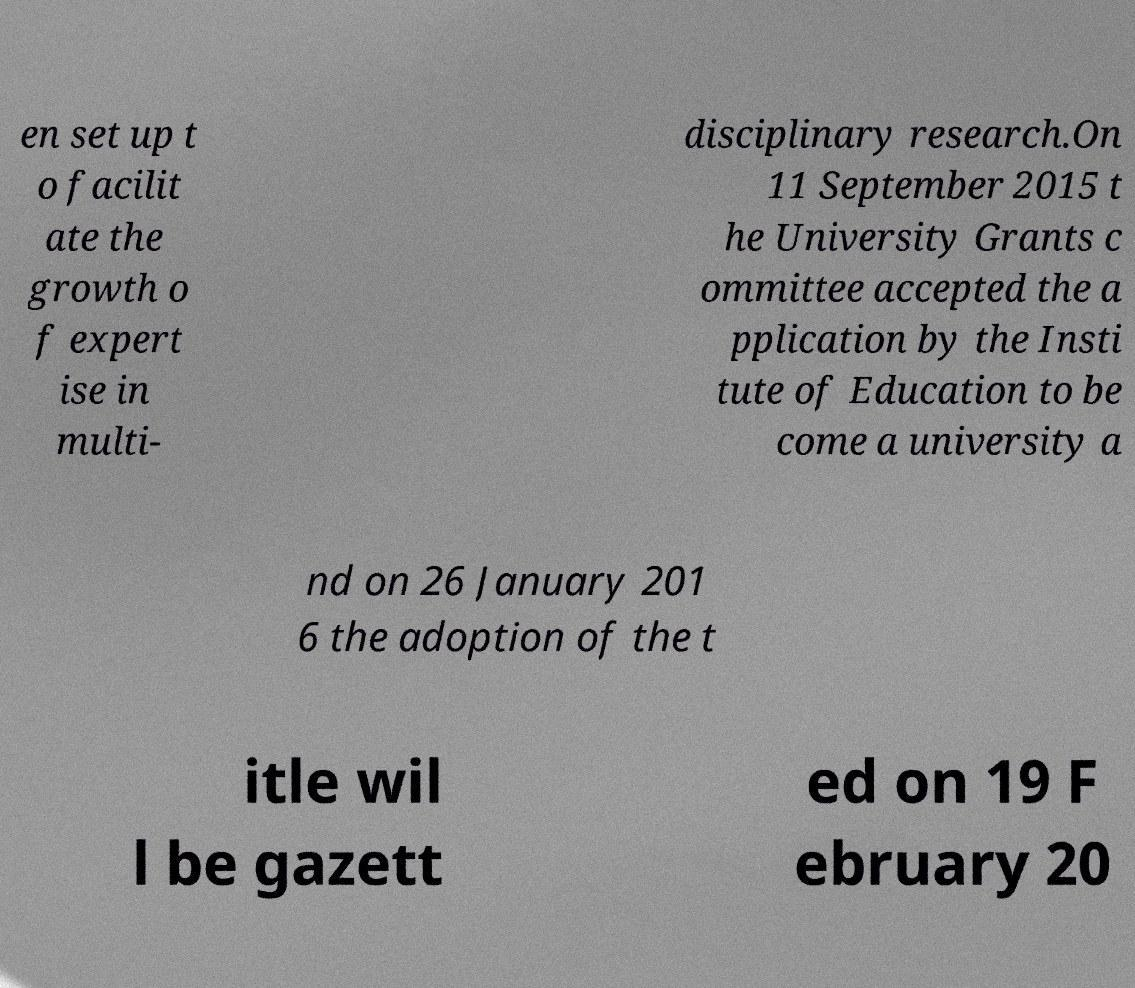What messages or text are displayed in this image? I need them in a readable, typed format. en set up t o facilit ate the growth o f expert ise in multi- disciplinary research.On 11 September 2015 t he University Grants c ommittee accepted the a pplication by the Insti tute of Education to be come a university a nd on 26 January 201 6 the adoption of the t itle wil l be gazett ed on 19 F ebruary 20 